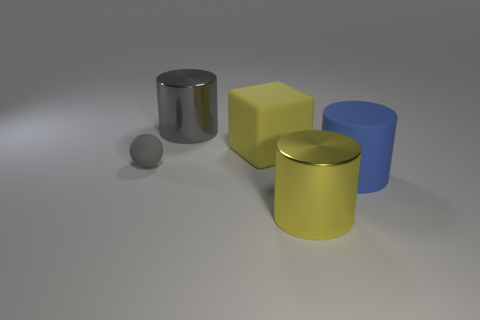Add 4 tiny cylinders. How many objects exist? 9 Subtract all blocks. How many objects are left? 4 Subtract all small yellow matte balls. Subtract all big rubber objects. How many objects are left? 3 Add 2 gray matte spheres. How many gray matte spheres are left? 3 Add 2 big yellow shiny objects. How many big yellow shiny objects exist? 3 Subtract 0 purple cylinders. How many objects are left? 5 